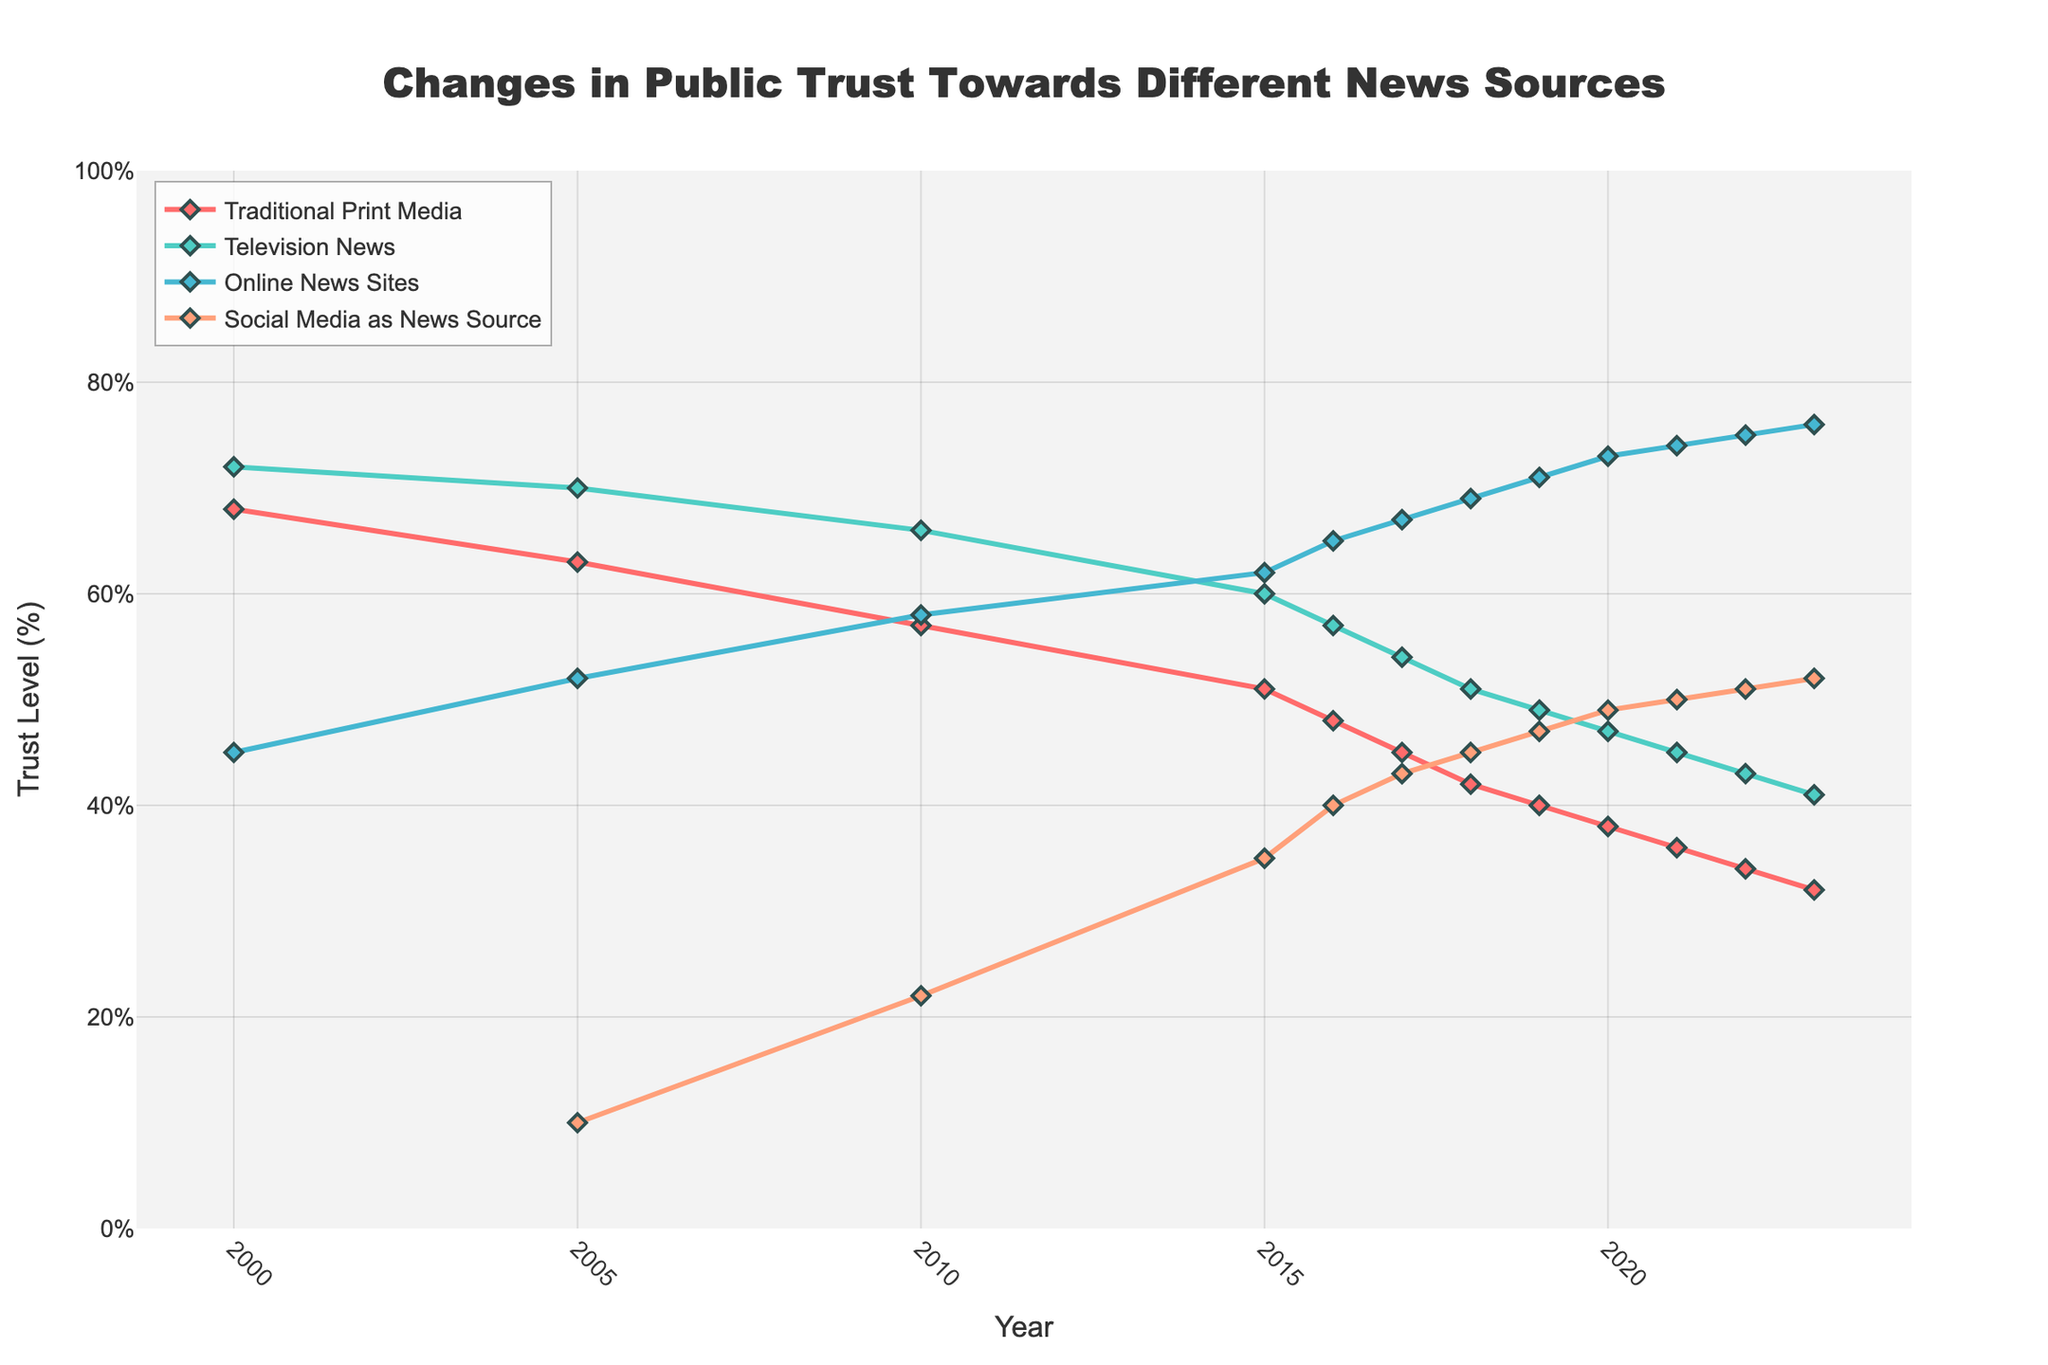When did Online News Sites first surpass Traditional Print Media in public trust? Find the point where the line representing Online News Sites crosses above the line for Traditional Print Media. This happens between 2010 and 2015, which is in the year 2015.
Answer: 2015 Which news source had the highest trust level in 2005? Compare the values of all news sources for the year 2005. Television News had a trust level of 70%, which is the highest compared to the others.
Answer: Television News In what year did Television News and Traditional Print Media have equal trust levels? Identify the year where the trust levels of Television News and Traditional Print Media intersect or have identical values. This occurs in 2023, both having around 41% trust.
Answer: 2023 How much did the trust in Traditional Print Media change from 2000 to 2023? Calculate the difference between trust levels of Traditional Print Media in 2000 (68%) and 2023 (32%), which is 68% - 32% = 36%.
Answer: 36% By how many percentage points did trust in Social Media as a News Source grow from 2005 to 2015? Look at the values for Social Media as a News Source in 2005 (10%) and 2015 (35%). The growth is 35% - 10% = 25%.
Answer: 25% What was the difference in trust levels between Online News Sites and Television News in 2020? Subtract the trust level of Television News (47%) from that of Online News Sites (73%) in 2020. The difference is 73% - 47% = 26%.
Answer: 26% Which news source had the largest increase in trust from 2005 to 2023? Calculate the increase for each source from 2005 to 2023. Social Media grew from 10% to 52%, an increase of 42%, and is the largest increase.
Answer: Social Media as News Source What is the average trust level of Online News Sites over the period 2000 to 2023? Sum the trust levels of Online News Sites for all years and divide by the number of years. (45+52+58+62+65+67+69+71+73+74+75+76) / 12 = 66.75%.
Answer: 66.75% Which news source had the smallest trust level in 2018? Compare the trust levels of all news sources in 2018. Traditional Print Media had the smallest trust level at 42%.
Answer: Traditional Print Media What was the general trend for trust in Traditional Print Media from 2000 to 2023? Observing the line for Traditional Print Media, identify the overall direction. It consistently declines from 68% in 2000 to 32% in 2023.
Answer: Declining 